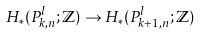<formula> <loc_0><loc_0><loc_500><loc_500>H _ { \ast } ( P _ { k , n } ^ { l } ; \mathbb { Z } ) \to H _ { \ast } ( P _ { k + 1 , n } ^ { l } ; \mathbb { Z } )</formula> 